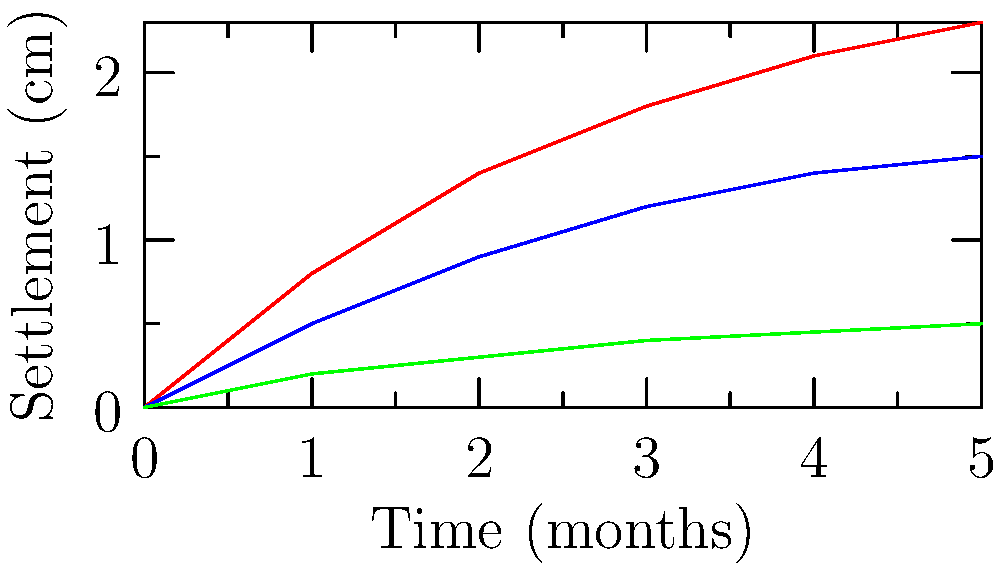As a military engineer tasked with constructing an airfield in Nigeria, you are presented with the above graph showing soil settlement over time for different soil types. Which soil type would be most suitable for rapid airfield construction, considering the need for minimal settlement and quick operational readiness? To determine the most suitable soil type for rapid airfield construction, we need to analyze the settlement characteristics of each soil type presented in the graph:

1. Sandy soil (red line):
   - Shows the highest overall settlement
   - Settles quickly in the first few months
   - Continues to settle significantly over time

2. Clay soil (blue line):
   - Shows moderate settlement
   - Settles more slowly than sandy soil
   - Continues to settle over time, but less than sandy soil

3. Rocky soil (green line):
   - Shows the least overall settlement
   - Settles very slowly
   - Minimal increase in settlement over time

For rapid airfield construction with minimal settlement and quick operational readiness, we need to consider:

a) Initial settlement: Rocky soil has the least initial settlement, allowing for faster construction.
b) Long-term stability: Rocky soil shows the least change over time, ensuring better long-term stability.
c) Operational readiness: The minimal settlement of rocky soil allows for quicker operational readiness of the airfield.

Therefore, rocky soil would be the most suitable choice for rapid airfield construction in this scenario. It provides the best balance of minimal initial settlement, long-term stability, and quick operational readiness, which are crucial factors for military airfield construction.
Answer: Rocky soil 